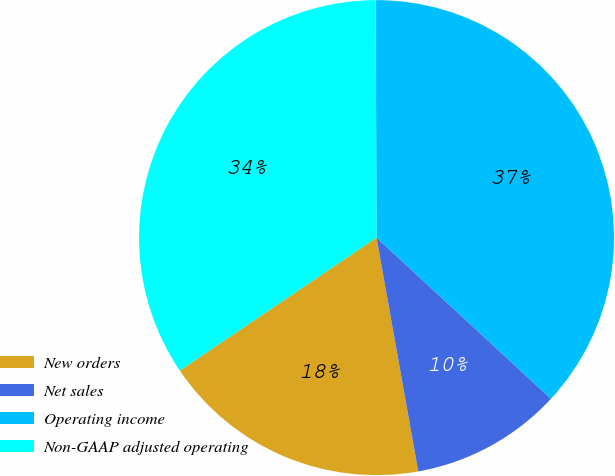<chart> <loc_0><loc_0><loc_500><loc_500><pie_chart><fcel>New orders<fcel>Net sales<fcel>Operating income<fcel>Non-GAAP adjusted operating<nl><fcel>18.35%<fcel>10.32%<fcel>36.93%<fcel>34.4%<nl></chart> 